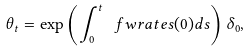Convert formula to latex. <formula><loc_0><loc_0><loc_500><loc_500>\theta _ { t } = \exp \left ( \int _ { 0 } ^ { t } \ f w r a t e { s } ( 0 ) d s \right ) \delta _ { 0 } ,</formula> 